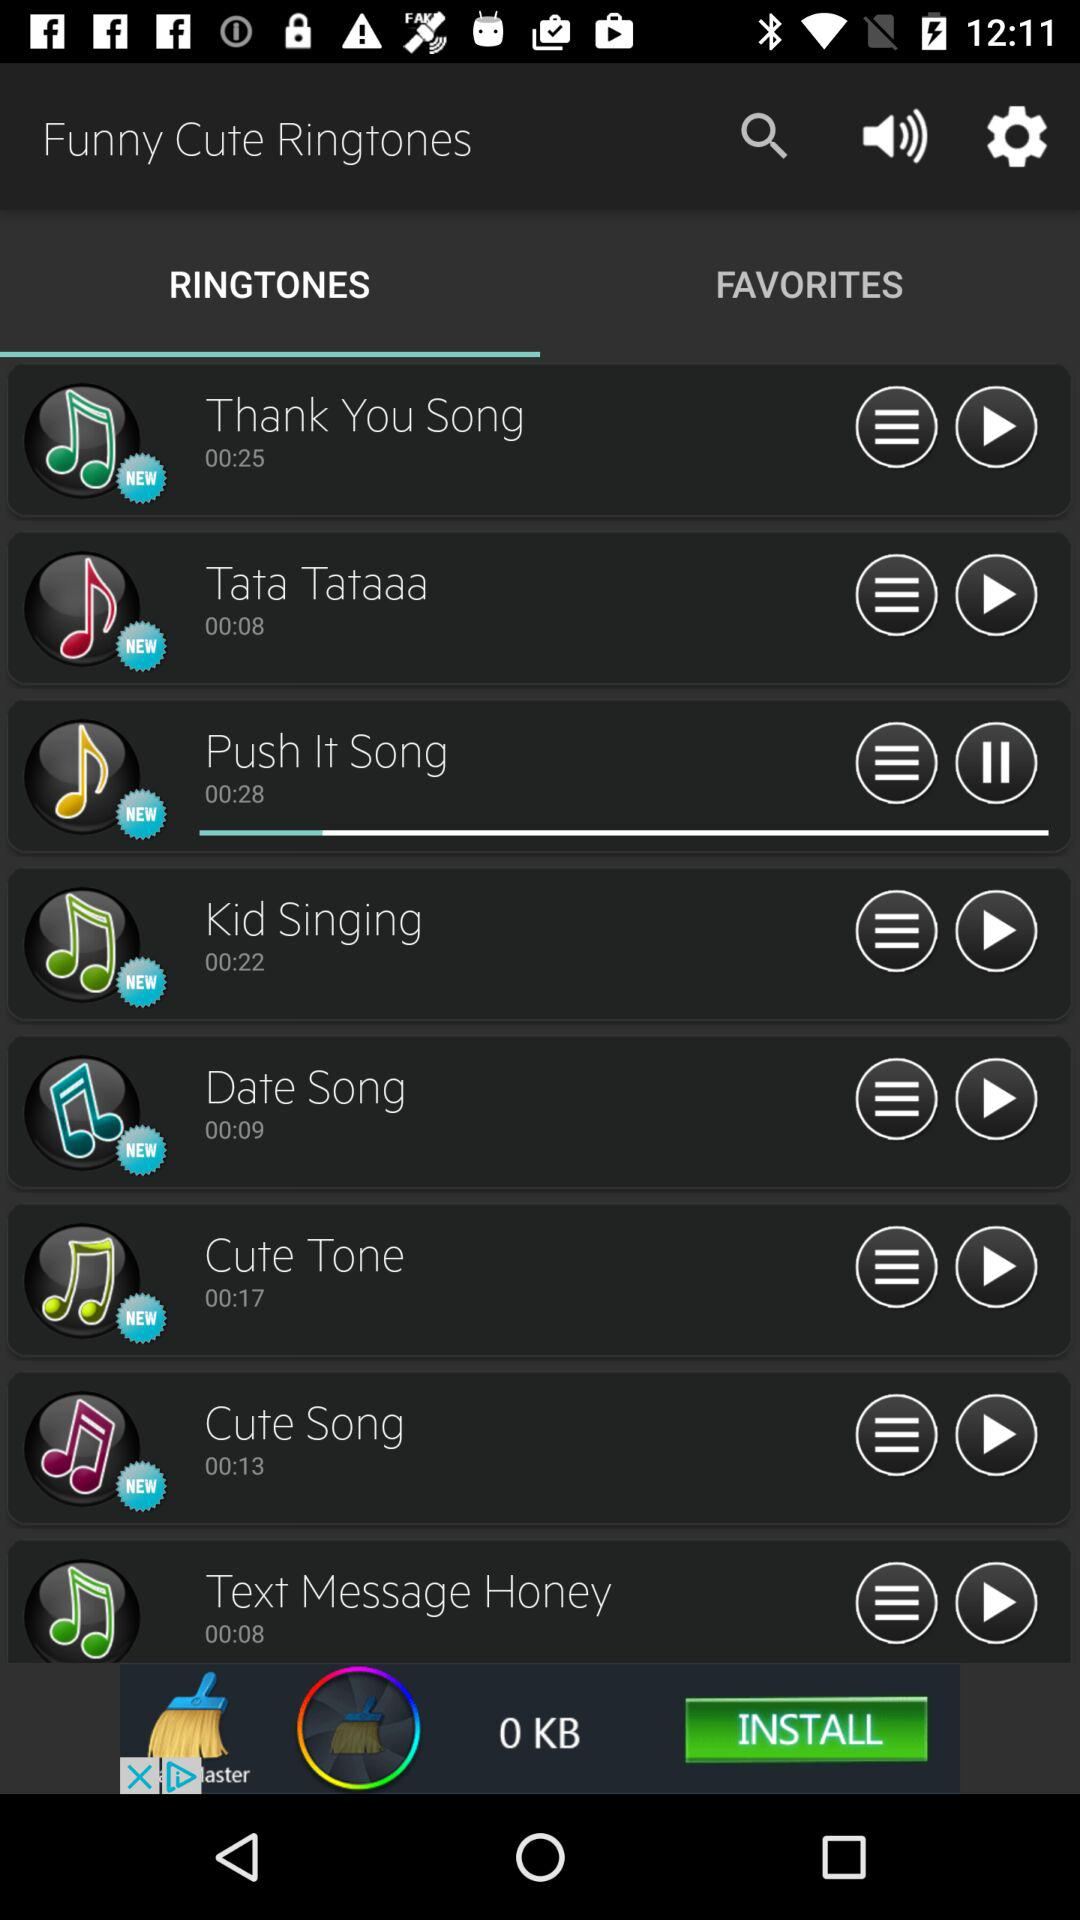What is the application name? The application name is "Funny Cute Ringtones". 